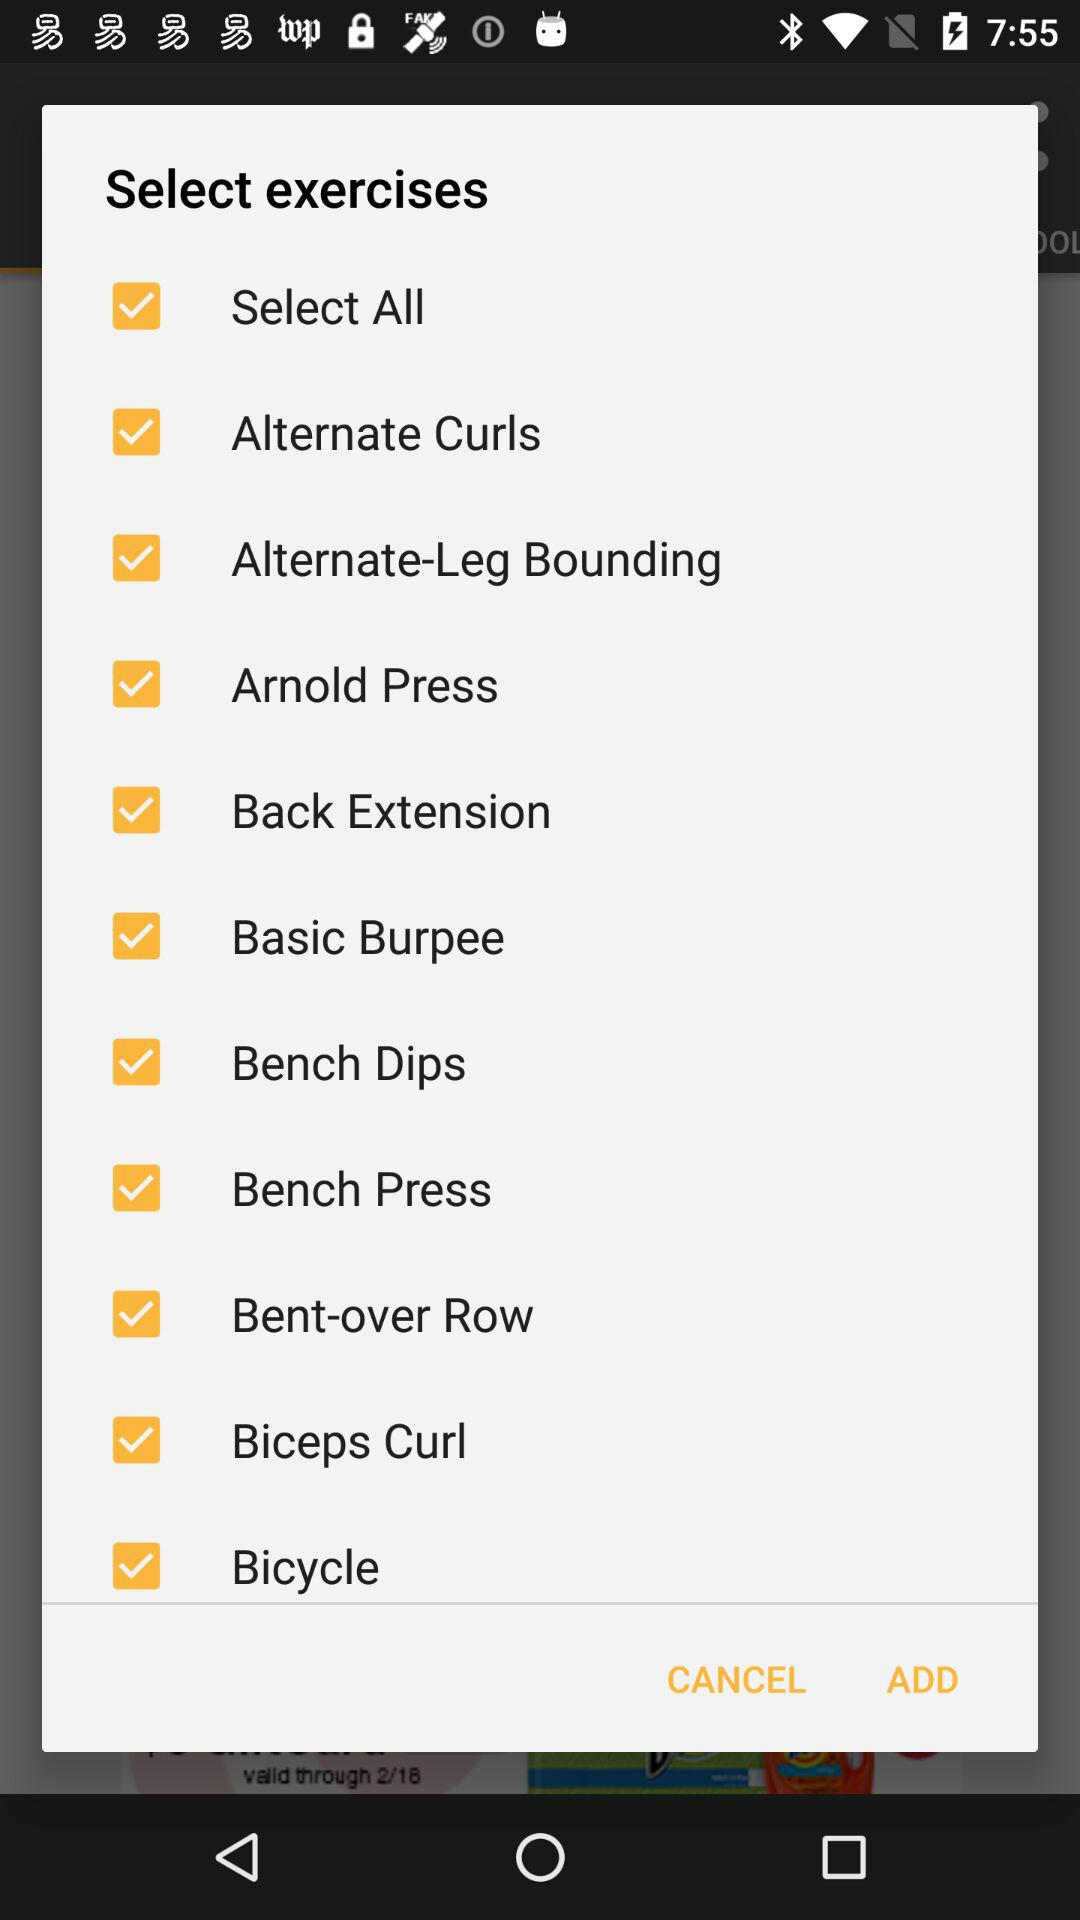What are the available options? The available options are "Select All", "Alternate Curls", "Alternate-Leg Bounding", "Arnold Press", "Back Extension", "Basic Burpee", "Bench Dips", "Bench Press", "Bent-over Row", "Biceps Curl" and "Bicycle". 